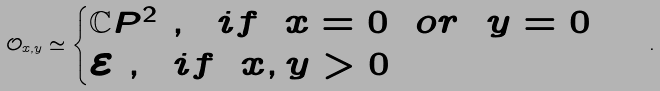<formula> <loc_0><loc_0><loc_500><loc_500>\mathcal { O } _ { x , y } \simeq \begin{cases} \mathbb { C } P ^ { 2 } \ , \ \ i f \ \ x = 0 \ \ o r \ \ y = 0 \\ \mathcal { E } \ , \ \ i f \ \ x , y > 0 \end{cases} \ .</formula> 